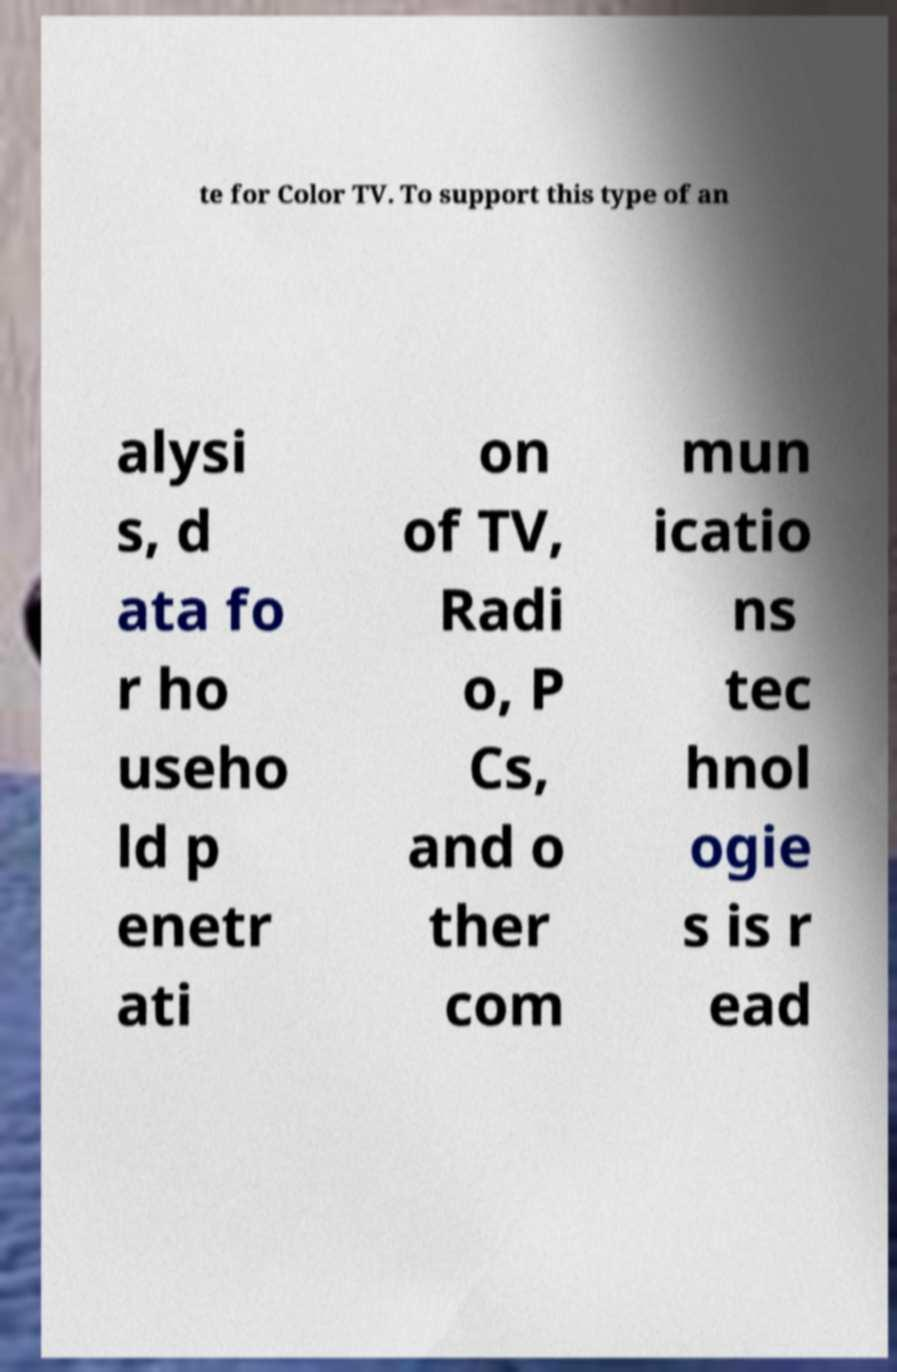For documentation purposes, I need the text within this image transcribed. Could you provide that? te for Color TV. To support this type of an alysi s, d ata fo r ho useho ld p enetr ati on of TV, Radi o, P Cs, and o ther com mun icatio ns tec hnol ogie s is r ead 